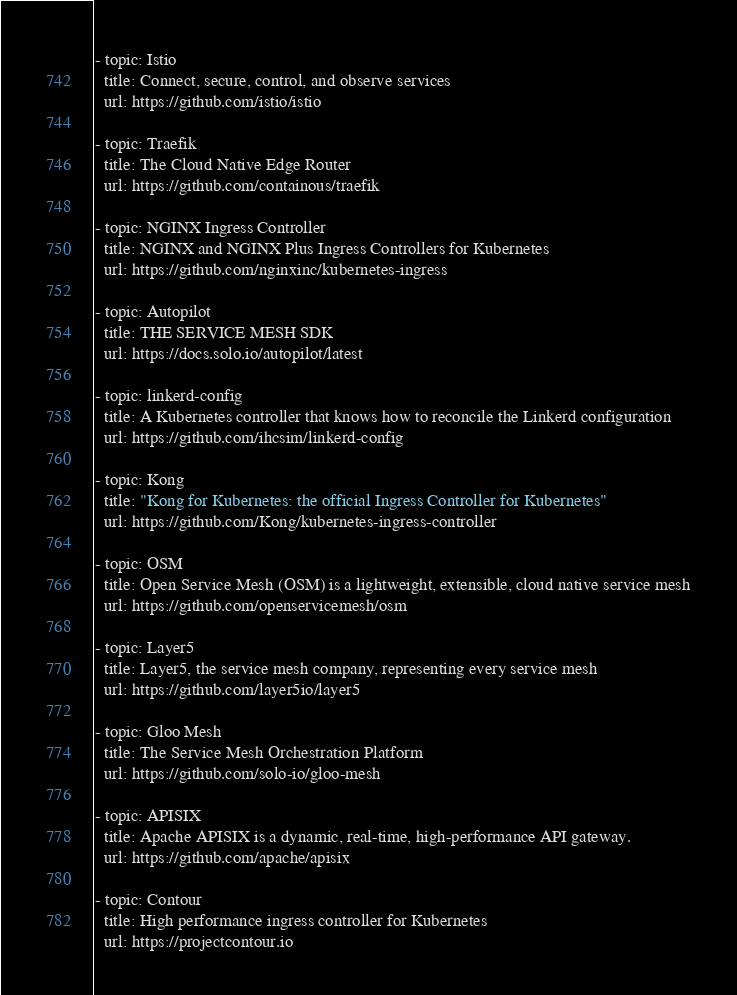Convert code to text. <code><loc_0><loc_0><loc_500><loc_500><_YAML_>
- topic: Istio
  title: Connect, secure, control, and observe services
  url: https://github.com/istio/istio

- topic: Traefik
  title: The Cloud Native Edge Router
  url: https://github.com/containous/traefik

- topic: NGINX Ingress Controller
  title: NGINX and NGINX Plus Ingress Controllers for Kubernetes
  url: https://github.com/nginxinc/kubernetes-ingress

- topic: Autopilot
  title: THE SERVICE MESH SDK
  url: https://docs.solo.io/autopilot/latest

- topic: linkerd-config
  title: A Kubernetes controller that knows how to reconcile the Linkerd configuration
  url: https://github.com/ihcsim/linkerd-config

- topic: Kong
  title: "Kong for Kubernetes: the official Ingress Controller for Kubernetes"
  url: https://github.com/Kong/kubernetes-ingress-controller

- topic: OSM
  title: Open Service Mesh (OSM) is a lightweight, extensible, cloud native service mesh
  url: https://github.com/openservicemesh/osm

- topic: Layer5
  title: Layer5, the service mesh company, representing every service mesh
  url: https://github.com/layer5io/layer5

- topic: Gloo Mesh
  title: The Service Mesh Orchestration Platform
  url: https://github.com/solo-io/gloo-mesh

- topic: APISIX
  title: Apache APISIX is a dynamic, real-time, high-performance API gateway.
  url: https://github.com/apache/apisix
  
- topic: Contour
  title: High performance ingress controller for Kubernetes
  url: https://projectcontour.io
</code> 